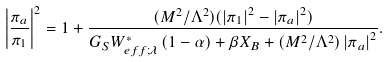Convert formula to latex. <formula><loc_0><loc_0><loc_500><loc_500>\left | \frac { \pi _ { a } } { \pi _ { 1 } } \right | ^ { 2 } = 1 + \frac { ( M ^ { 2 } / \Lambda ^ { 2 } ) ( \left | \pi _ { 1 } \right | ^ { 2 } - \left | \pi _ { a } \right | ^ { 2 } ) } { G _ { S } W _ { e f f ; \lambda } ^ { \ast } \left ( 1 - \alpha \right ) + \beta X _ { B } + ( M ^ { 2 } / \Lambda ^ { 2 } ) \left | \pi _ { a } \right | ^ { 2 } } .</formula> 